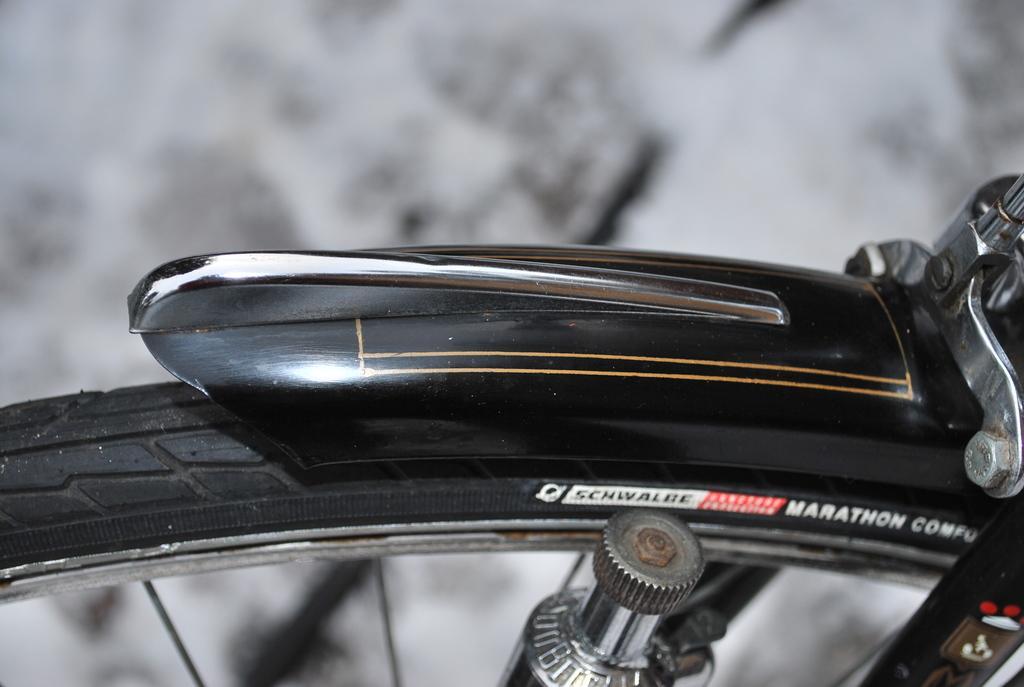Could you give a brief overview of what you see in this image? There is a wheel of a black bicycle. Some matter is written on it. The background is blurred. 